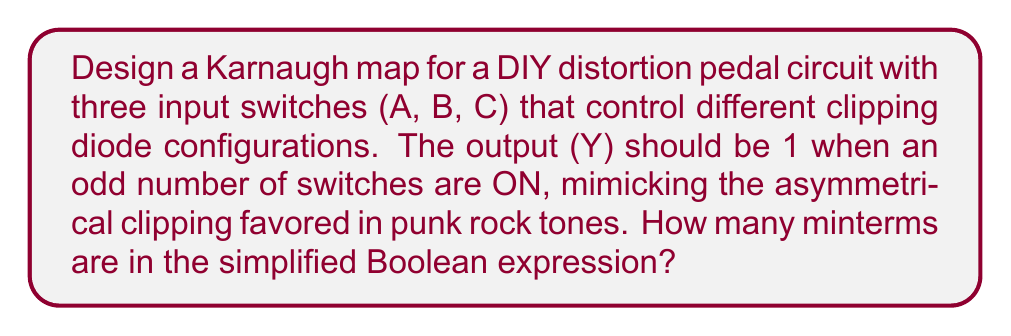What is the answer to this math problem? Let's approach this step-by-step:

1) First, we need to create a truth table for the given conditions:

   A | B | C | Y
   0 | 0 | 0 | 0
   0 | 0 | 1 | 1
   0 | 1 | 0 | 1
   0 | 1 | 1 | 0
   1 | 0 | 0 | 1
   1 | 0 | 1 | 0
   1 | 1 | 0 | 0
   1 | 1 | 1 | 1

2) Now, let's create the Karnaugh map:

   [asy]
   unitsize(1cm);
   
   draw((0,0)--(4,0)--(4,2)--(0,2)--cycle);
   draw((1,0)--(1,2));
   draw((2,0)--(2,2));
   draw((3,0)--(3,2));
   draw((0,1)--(4,1));
   
   label("AB\C", (0,2.3));
   label("00", (0.5,2.3));
   label("01", (1.5,2.3));
   label("11", (2.5,2.3));
   label("10", (3.5,2.3));
   
   label("00", (-0.3,1.5));
   label("01", (-0.3,0.5));
   
   label("0", (0.5,1.5));
   label("1", (1.5,1.5));
   label("1", (2.5,1.5));
   label("1", (3.5,1.5));
   label("1", (0.5,0.5));
   label("0", (1.5,0.5));
   label("1", (2.5,0.5));
   label("0", (3.5,0.5));
   [/asy]

3) From the Karnaugh map, we can see that there are no groups of 4 or 2 that can be combined.

4) Therefore, the simplified Boolean expression will include all the 1's in the map as separate minterms:

   $$Y = \overline{A}\overline{B}C + \overline{A}B\overline{C} + A\overline{B}\overline{C} + ABC$$

5) Counting the minterms in this expression, we see there are 4 minterms.
Answer: 4 